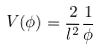Convert formula to latex. <formula><loc_0><loc_0><loc_500><loc_500>V ( \phi ) = \frac { 2 } { l ^ { 2 } } \frac { 1 } { \phi }</formula> 